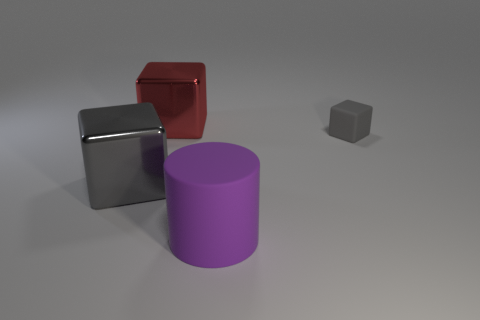Are there any tiny gray cubes right of the tiny matte thing?
Keep it short and to the point. No. There is a big thing that is the same color as the tiny block; what material is it?
Your answer should be compact. Metal. There is a gray rubber thing; is it the same size as the object in front of the large gray cube?
Offer a terse response. No. Are there any big metallic things of the same color as the small rubber thing?
Your response must be concise. Yes. Is there a green shiny thing that has the same shape as the big purple object?
Make the answer very short. No. The thing that is behind the big gray object and on the left side of the small gray rubber object has what shape?
Offer a very short reply. Cube. How many other gray blocks are made of the same material as the small gray block?
Your answer should be compact. 0. Are there fewer shiny things behind the big red cube than big blue rubber cubes?
Give a very brief answer. No. Are there any large gray blocks to the right of the big metallic object right of the large gray metallic object?
Provide a succinct answer. No. Is there anything else that has the same shape as the small matte thing?
Your response must be concise. Yes. 